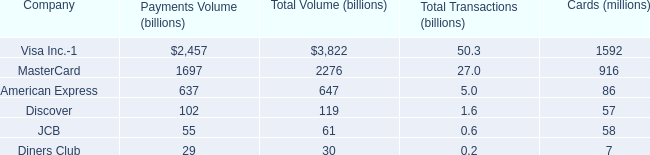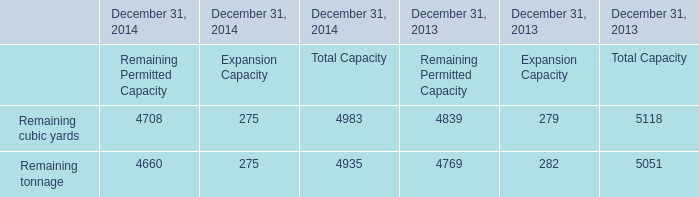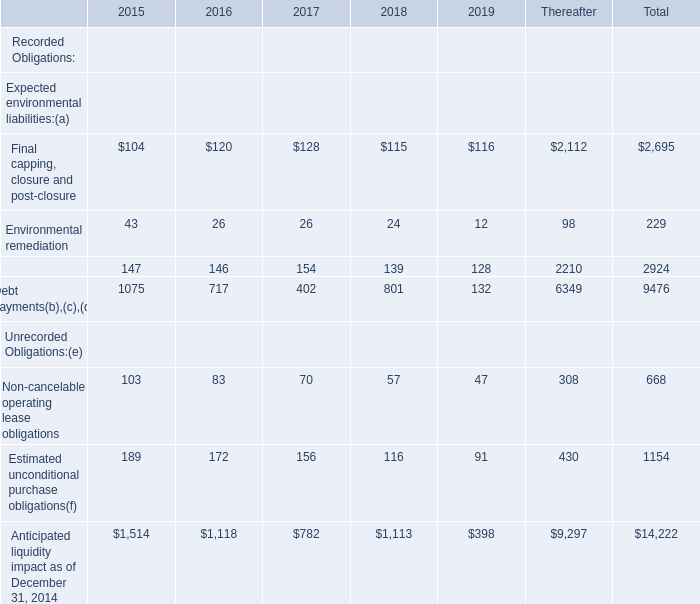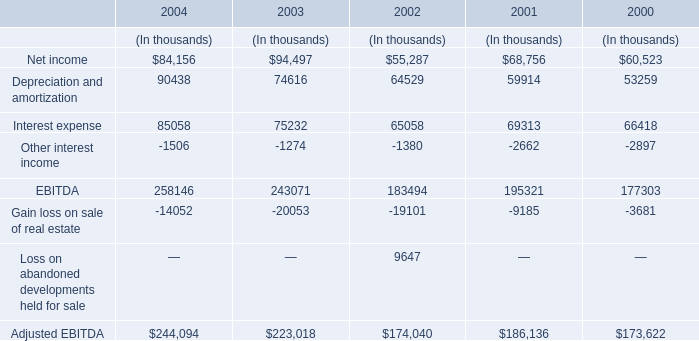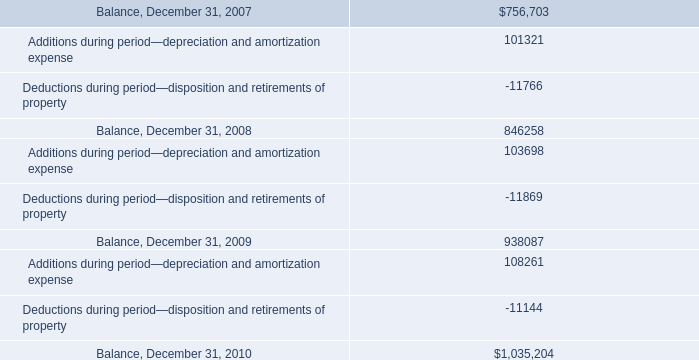considering the years 2009-2010 , what is the increase in the final balance? 
Computations: ((1035204 / 938087) - 1)
Answer: 0.10353. 